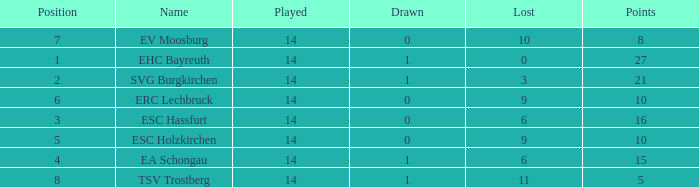What's the lost when there were more than 16 points and had a drawn less than 1? None. 